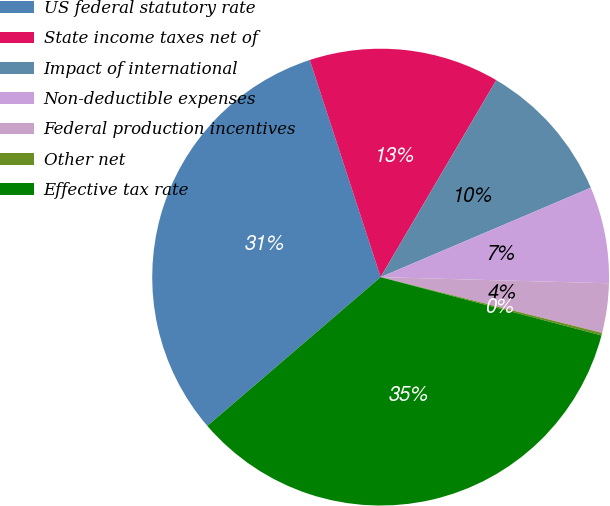Convert chart. <chart><loc_0><loc_0><loc_500><loc_500><pie_chart><fcel>US federal statutory rate<fcel>State income taxes net of<fcel>Impact of international<fcel>Non-deductible expenses<fcel>Federal production incentives<fcel>Other net<fcel>Effective tax rate<nl><fcel>31.27%<fcel>13.47%<fcel>10.15%<fcel>6.83%<fcel>3.5%<fcel>0.18%<fcel>34.6%<nl></chart> 